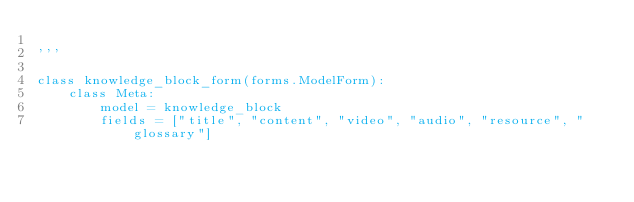Convert code to text. <code><loc_0><loc_0><loc_500><loc_500><_Python_>
'''

class knowledge_block_form(forms.ModelForm):
    class Meta:
        model = knowledge_block
        fields = ["title", "content", "video", "audio", "resource", "glossary"]
</code> 